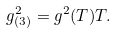<formula> <loc_0><loc_0><loc_500><loc_500>g _ { ( 3 ) } ^ { 2 } = g ^ { 2 } ( T ) T .</formula> 